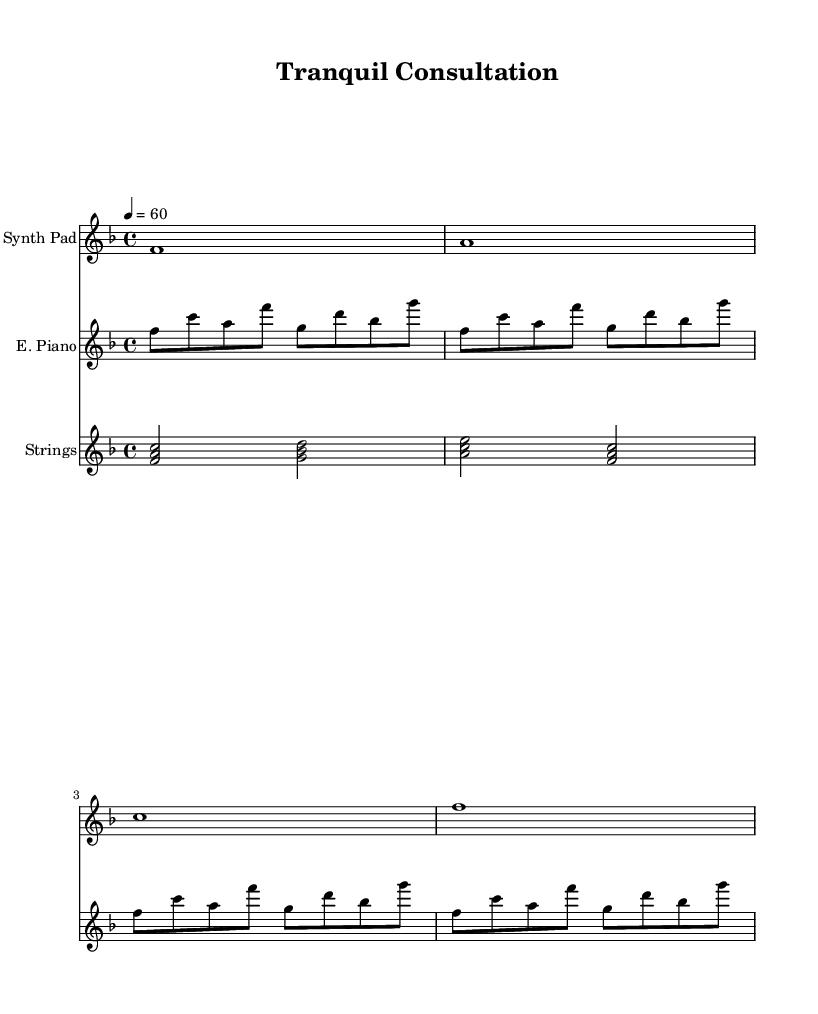What is the key signature of this music? The key signature indicated is F major, which has one flat (B flat).
Answer: F major What is the time signature of this music? The time signature given is 4/4, which means there are four beats in a measure.
Answer: 4/4 What is the tempo marking of this music? The tempo marking shows a quarter note equals 60 beats per minute, indicating a slow, calming pace.
Answer: 60 How many instruments are used in this score? The score includes three distinct staves, each representing a different instrument: Synth Pad, Electric Piano, and Strings.
Answer: Three What is the note duration of the first measure in the Synth Pad? The first measure has a whole note (F), which lasts for four beats according to the 4/4 time signature.
Answer: Whole note Which instrument plays a repeated pattern? The Electric Piano plays a repeated sequence of notes, outlined in the measure with the "repeat unfold" syntax indicating repetition.
Answer: Electric Piano What type of harmony is used in the Strings part? The Strings part features chords played in a lush and layered style which complements the other instruments, characteristic of electronic music soundscapes.
Answer: Chords 